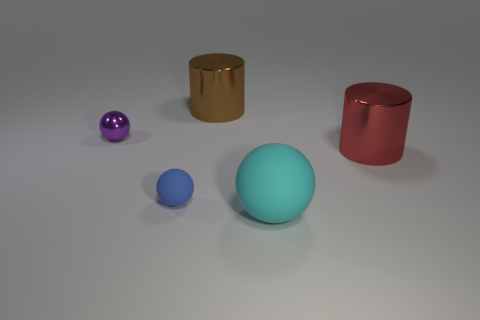Add 1 big rubber spheres. How many objects exist? 6 Subtract all small purple shiny balls. How many balls are left? 2 Subtract all cylinders. How many objects are left? 3 Subtract 1 balls. How many balls are left? 2 Add 3 large green shiny cubes. How many large green shiny cubes exist? 3 Subtract 0 green cylinders. How many objects are left? 5 Subtract all cyan cylinders. Subtract all cyan cubes. How many cylinders are left? 2 Subtract all big objects. Subtract all large yellow shiny cylinders. How many objects are left? 2 Add 4 small blue things. How many small blue things are left? 5 